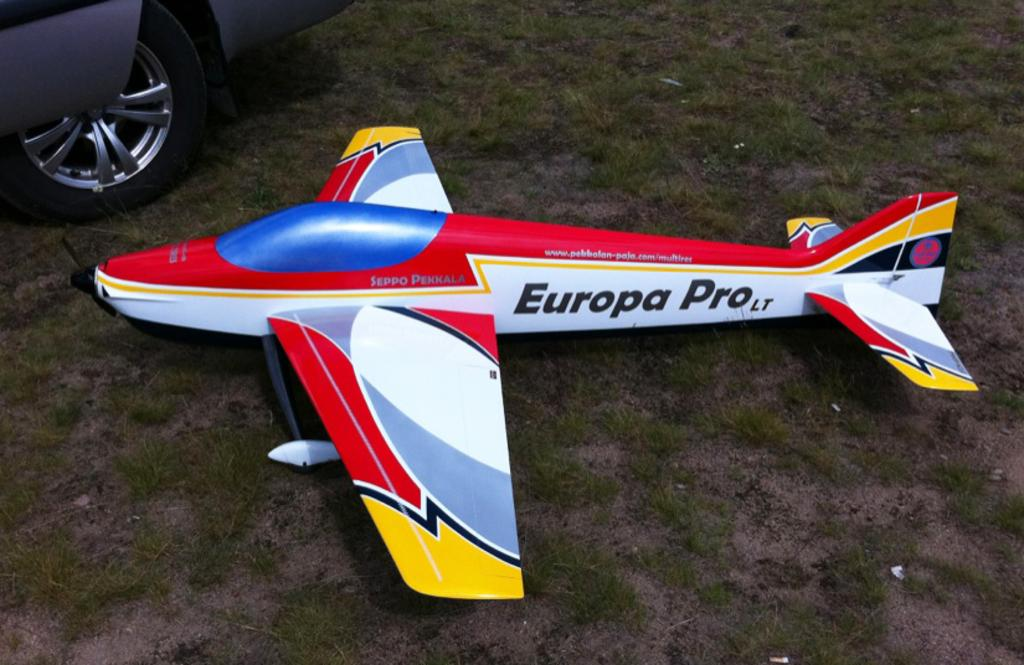What is the main object in the image? There is an aeroplane toy in the image. Where is the aeroplane toy located? The aeroplane toy is on grassy land. Can you identify any other objects in the image? Yes, there is a car in the top left corner of the image. Is the aeroplane toy attacking any other objects in the image? No, there is no attack depicted in the image. The aeroplane toy is simply located on grassy land. 